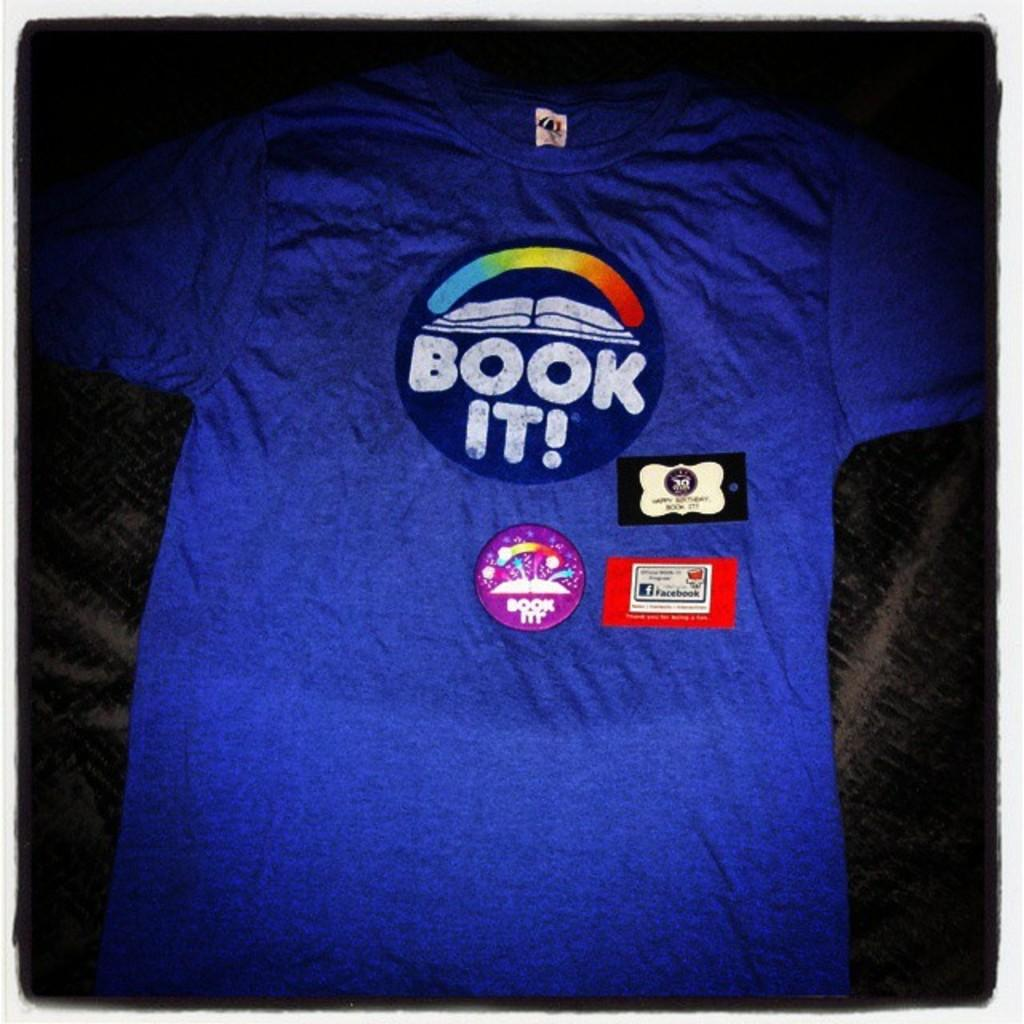<image>
Summarize the visual content of the image. A t-shirt with the Book It logo on it also has a Book It pin on it. 